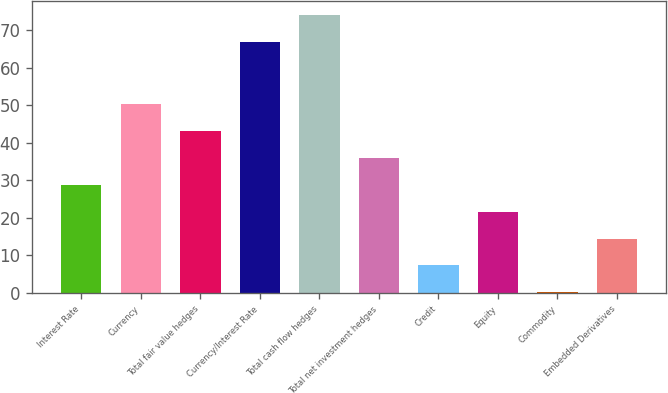Convert chart to OTSL. <chart><loc_0><loc_0><loc_500><loc_500><bar_chart><fcel>Interest Rate<fcel>Currency<fcel>Total fair value hedges<fcel>Currency/Interest Rate<fcel>Total cash flow hedges<fcel>Total net investment hedges<fcel>Credit<fcel>Equity<fcel>Commodity<fcel>Embedded Derivatives<nl><fcel>28.87<fcel>50.44<fcel>43.25<fcel>67<fcel>74.19<fcel>36.06<fcel>7.3<fcel>21.68<fcel>0.11<fcel>14.49<nl></chart> 